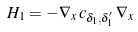Convert formula to latex. <formula><loc_0><loc_0><loc_500><loc_500>H _ { 1 } = - \nabla _ { x } \, c _ { \delta _ { 1 } , \delta _ { 1 } ^ { \prime } } \, \nabla _ { x }</formula> 